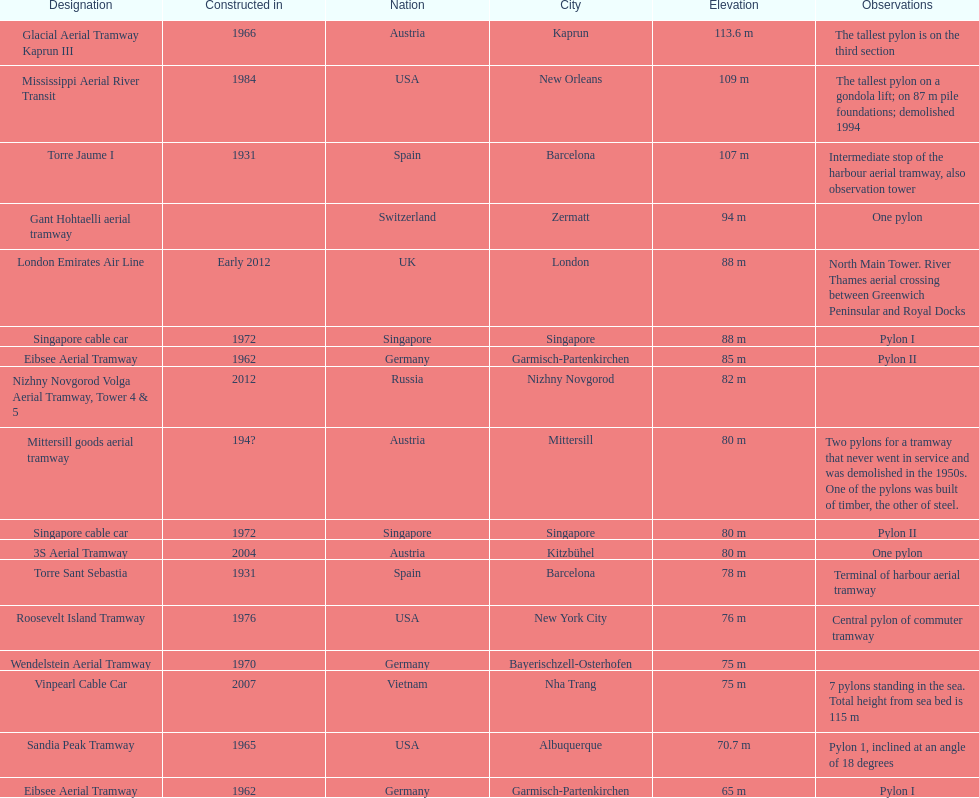What year was the last pylon in germany built? 1970. 